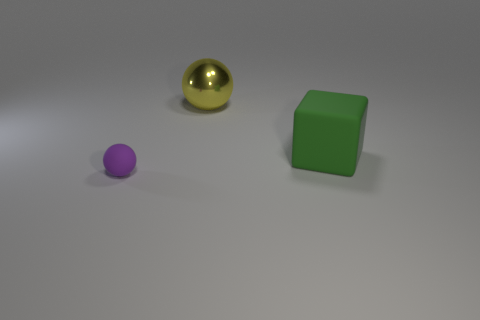What shape is the other object that is the same material as the green thing?
Keep it short and to the point. Sphere. Is there anything else that has the same shape as the big yellow thing?
Your response must be concise. Yes. What number of big green matte things are in front of the big green object?
Give a very brief answer. 0. Are there an equal number of large green blocks that are in front of the rubber block and big red balls?
Give a very brief answer. Yes. Does the big green cube have the same material as the tiny sphere?
Ensure brevity in your answer.  Yes. How big is the thing that is behind the tiny matte ball and in front of the big yellow object?
Give a very brief answer. Large. What number of green objects have the same size as the purple thing?
Give a very brief answer. 0. Is the number of big cubes the same as the number of blue shiny balls?
Your response must be concise. No. There is a sphere behind the rubber object on the left side of the metal ball; how big is it?
Your response must be concise. Large. There is a matte object that is behind the small purple object; is it the same shape as the big thing behind the green rubber object?
Keep it short and to the point. No. 